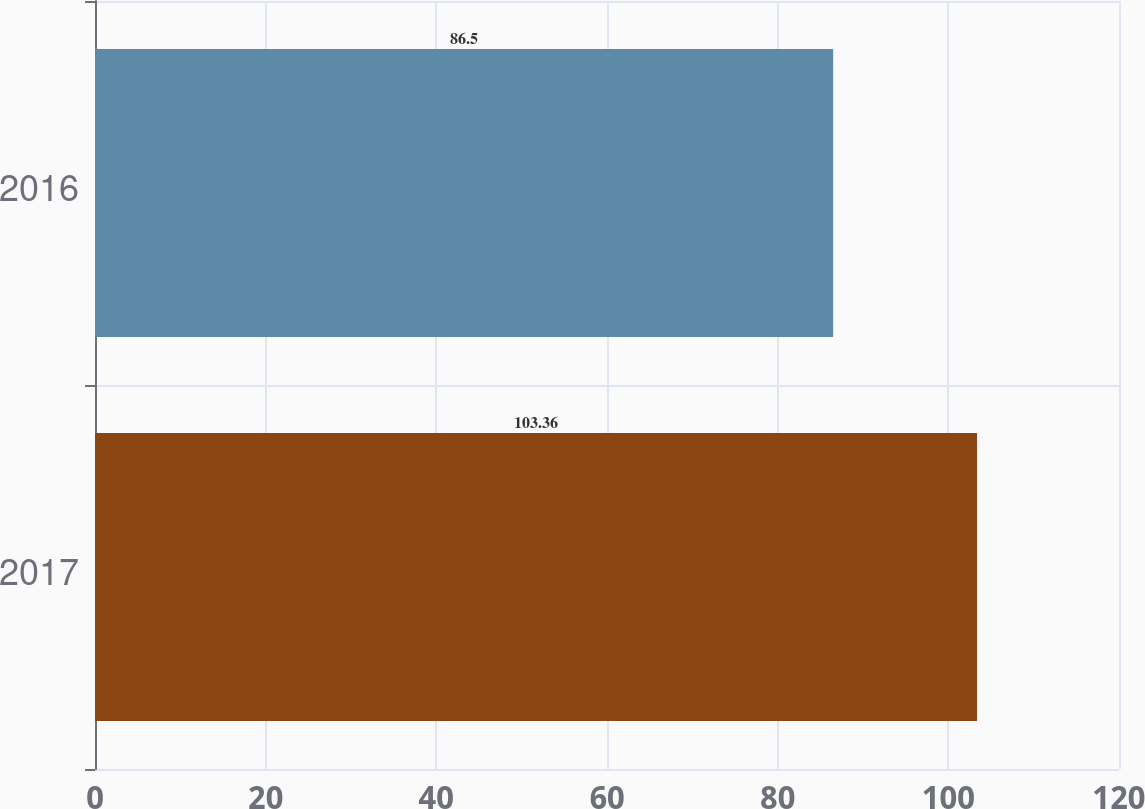Convert chart. <chart><loc_0><loc_0><loc_500><loc_500><bar_chart><fcel>2017<fcel>2016<nl><fcel>103.36<fcel>86.5<nl></chart> 